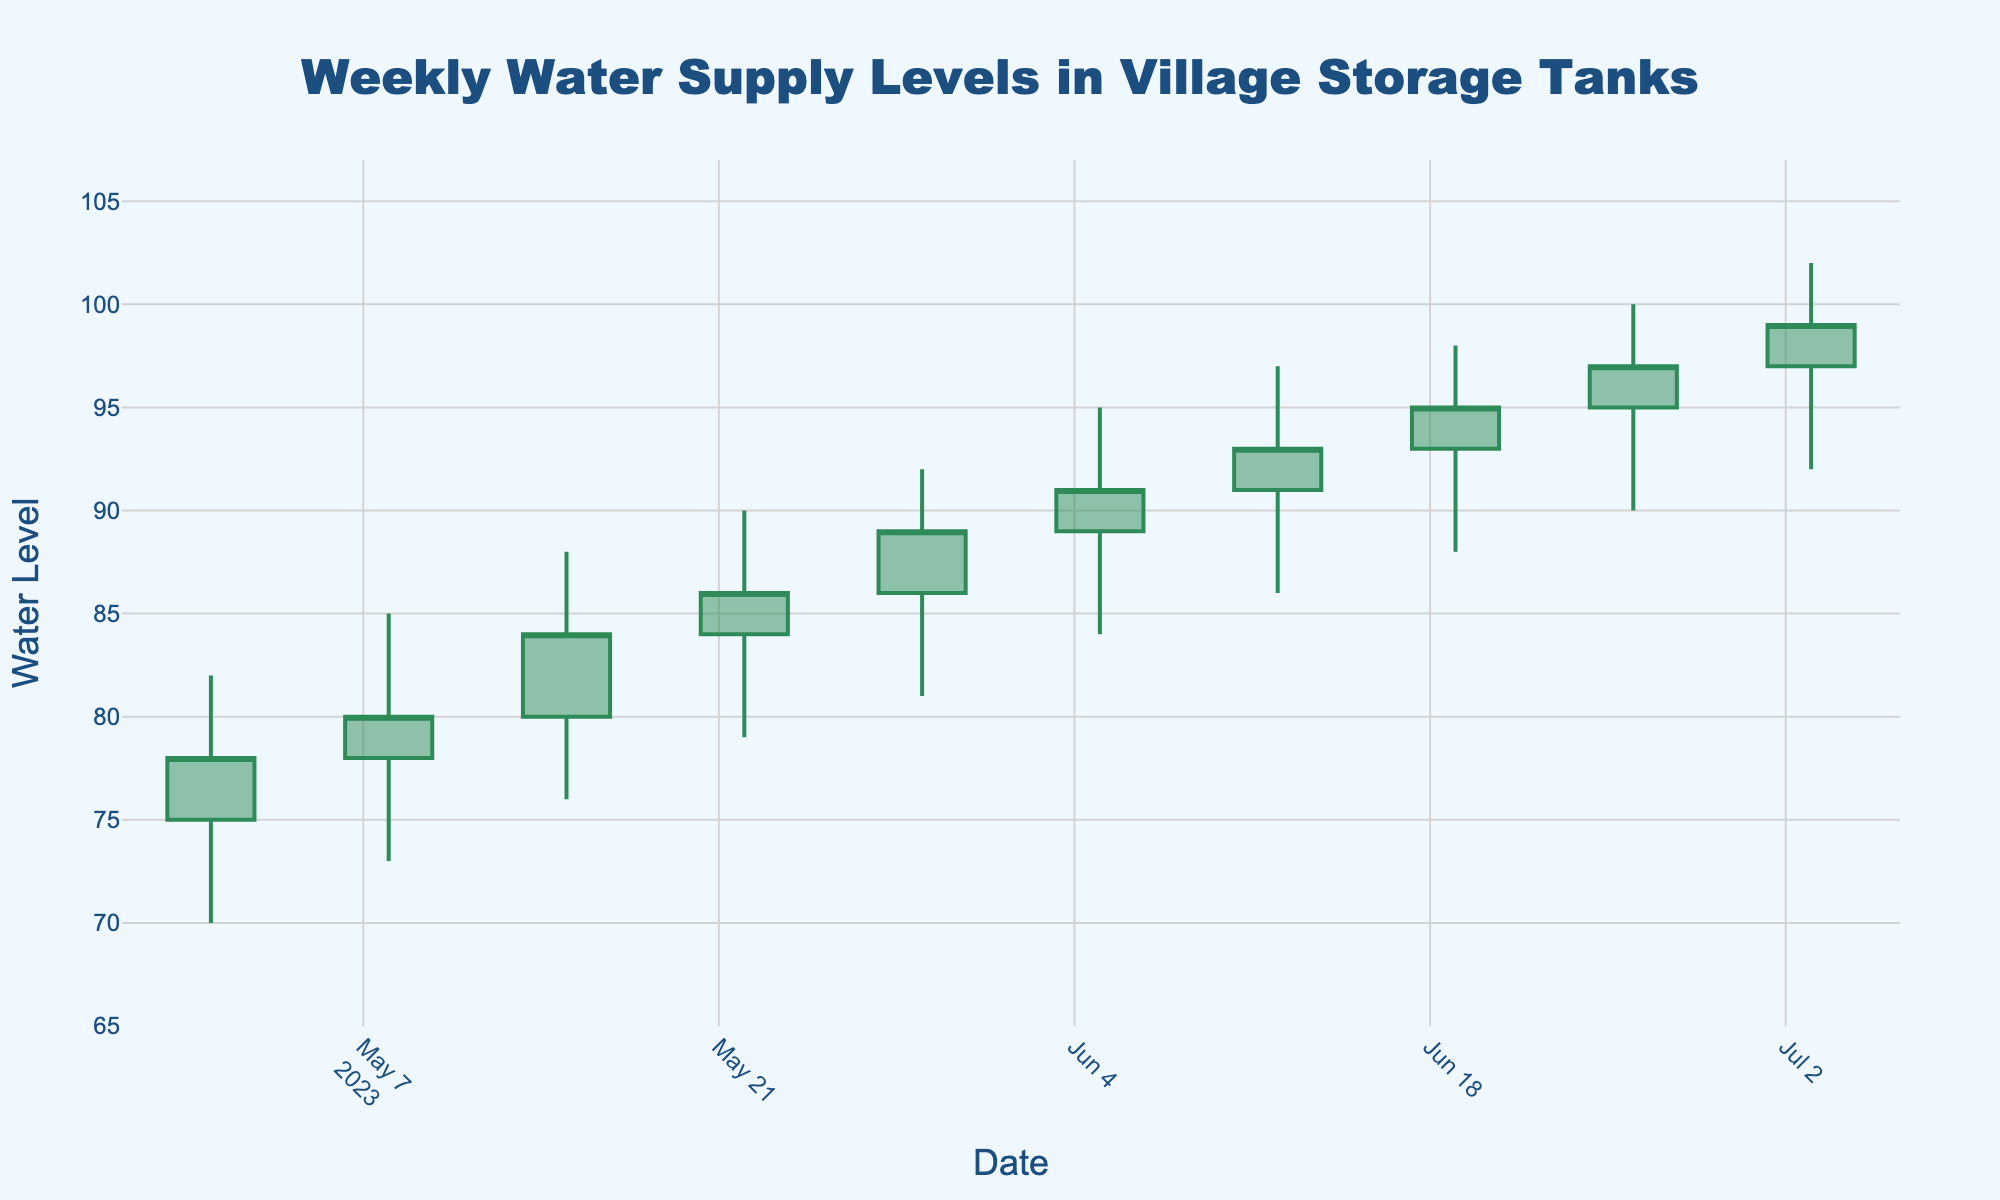What's the title of the chart? The title of the chart is prominently displayed at the top. It reads "Weekly Water Supply Levels in Village Storage Tanks."
Answer: Weekly Water Supply Levels in Village Storage Tanks How many weeks of data are represented in the chart? The x-axis displays each week's date, and there are 10 distinct weeks shown from May 1, 2023, to July 3, 2023.
Answer: 10 weeks Which week had the highest recorded water supply level? The "High" value is highest on July 3, 2023, at 102. This can be easily identified by looking for the tallest candlestick.
Answer: Week of July 3, 2023 What was the opening water supply level on June 12, 2023? The "Open" value for June 12, 2023, can be found as the starting point of the candlestick for that date. It is 91.
Answer: 91 What is the average closing water supply level for the three weeks from May 22, 2023, to June 5, 2023? The "Close" values for May 22 (86), May 29 (89), and June 5 (91) need to be summed and divided by 3. (86 + 89 + 91) / 3 = 88.67
Answer: 88.67 What is the overall trend in the closing water supply levels from May 1, 2023, to July 3, 2023? To determine the trend, observe the "Close" values sequentially. They generally increase from 78 on May 1 to 99 on July 3, indicating an upward trend.
Answer: Upward trend Which week showed the smallest range of water supply levels (difference between high and low)? The range for each week can be calculated. For May 1: 82-70=12, May 8: 85-73=12, and so on. The smallest range is for May 1, 2023, and May 8, 2023, both with a range of 12.
Answer: Week of May 1, 2023, and May 8, 2023 What's the difference between the closing water levels of May 1, 2023, and July 3, 2023? The "Close" value for May 1 is 78 and for July 3 is 99. The difference is 99 - 78 = 21.
Answer: 21 What was the water supply level at its lowest point, and in which week did it occur? The "Low" column values indicate the lowest points. The lowest level is 70, which occurred in the week of May 1, 2023.
Answer: 70, Week of May 1, 2023 During which week did the water supply level first surpass 90 in closing value? By checking each week's "Close" value, it is found that the water level first surpassed 90 in the week of June 5, 2023, where the closing value is 91.
Answer: Week of June 5, 2023 